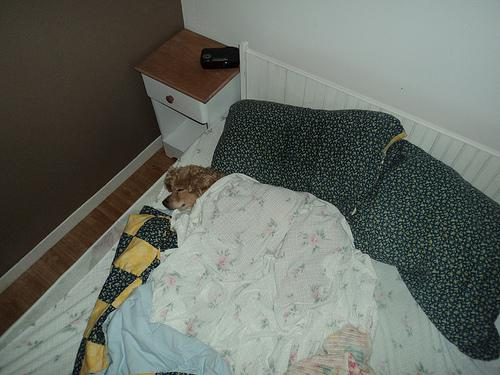Describe the location and design of the side table and the alarm clock. The side table, located to the left of the bed, has a wooden top and a brown knob on its top drawer, while the black alarm clock is positioned on the nightstand. Discuss the dog's position in the image and what it is surrounded by. The dog is situated on a bed in the middle of the image, engulfed by various blankets and pillows, with a white headboard behind it and a nightstand and alarm clock nearby. Talk about the scene's setting and the major elements present in it. Set in a bedroom, a dog is laying on a bed surrounded by colorful blankets and pillows, with a white headboard, and a nightstand featuring a black alarm clock. Choose three objects and describe their positions in the image. A dog is on the bed in the center, an alarm clock is on the nightstand to its right, and a white headboard is behind the bed with pillows on top. Mention three primary objects in the image and their function or purpose. A dog resting on the bed, a white headboard providing support behind the pillows, and an alarm clock on the nightstand for timekeeping. Briefly describe the image focusing on the main object. A dog is resting on a bed covered in blankets with a white headboard and a nightstand hosting an alarm clock. Mention the primary elements of the image in a single sentence. A dog comfortably resting on a bed with pillows, blankets, a white headboard, and an alarm clock on the white nightstand. Explain the scene's primary subject and any secondary objects. The main subject is a dog lying under multiple blankets on a bed, with secondary objects like pillows, a white headboard, and a nightstand with an alarm clock on top. Provide a detailed description of the image concentrating on its subject and color scheme. A cozy bedroom scene featuring a dog lounging on a bed with a mixture of colorful blankets and pillows, framed by a white headboard and dark brown walls and complemented by a white nightstand with an alarm clock. Elaborate on the central focus of the image and its surrounding elements. The image features a dog covered by a variety of blankets on a bed, with pillows, a white picket fence style headboard, and a nightstand holding an alarm clock on its wooden top. 